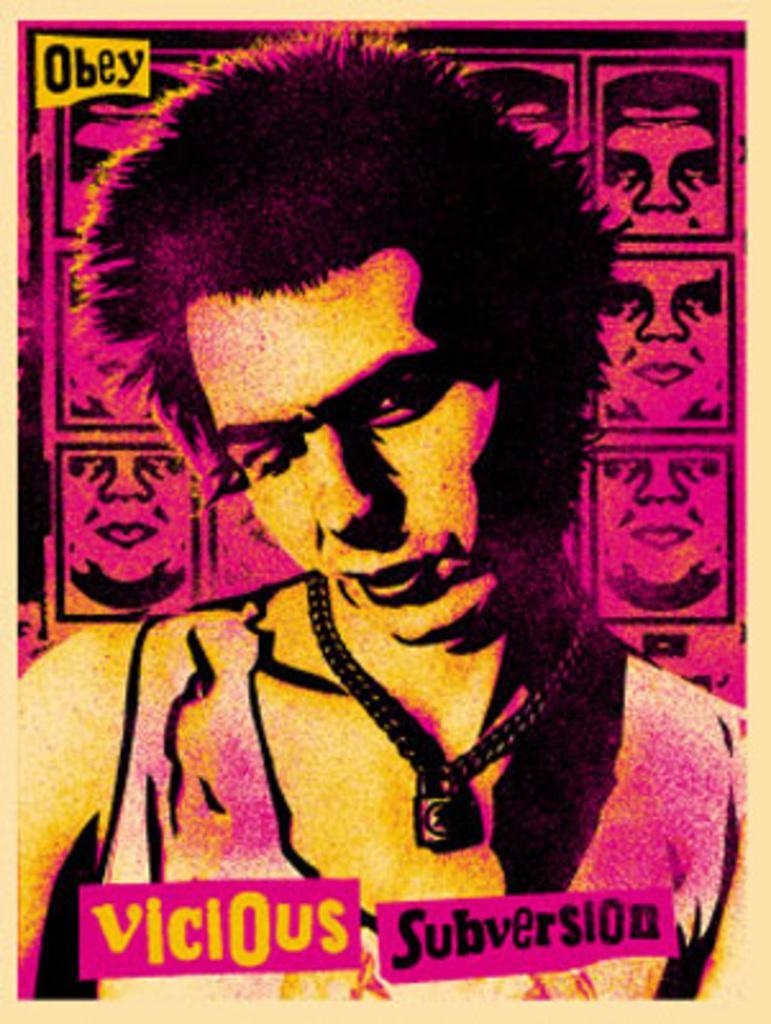Describe this image in one or two sentences. This image consists of a poster with an image of a man and there is a text on it. 